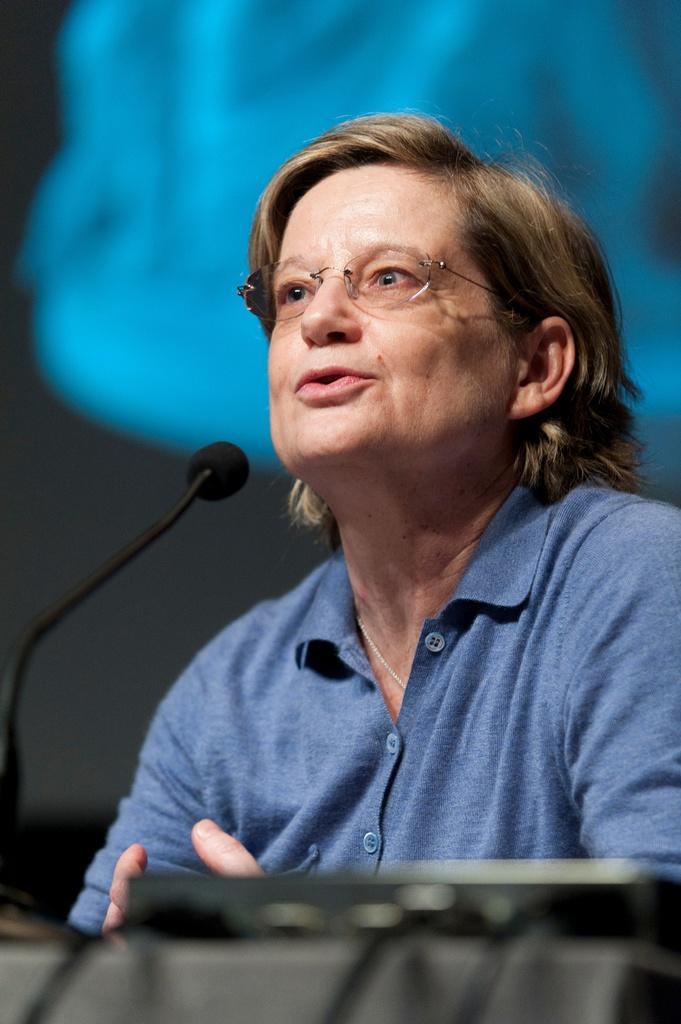Could you give a brief overview of what you see in this image? In this image we can see a woman and a mic before her. 